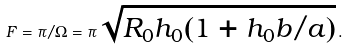<formula> <loc_0><loc_0><loc_500><loc_500>F = \pi / \Omega = \pi \sqrt { R _ { 0 } h _ { 0 } ( 1 + h _ { 0 } b / a ) } \, .</formula> 